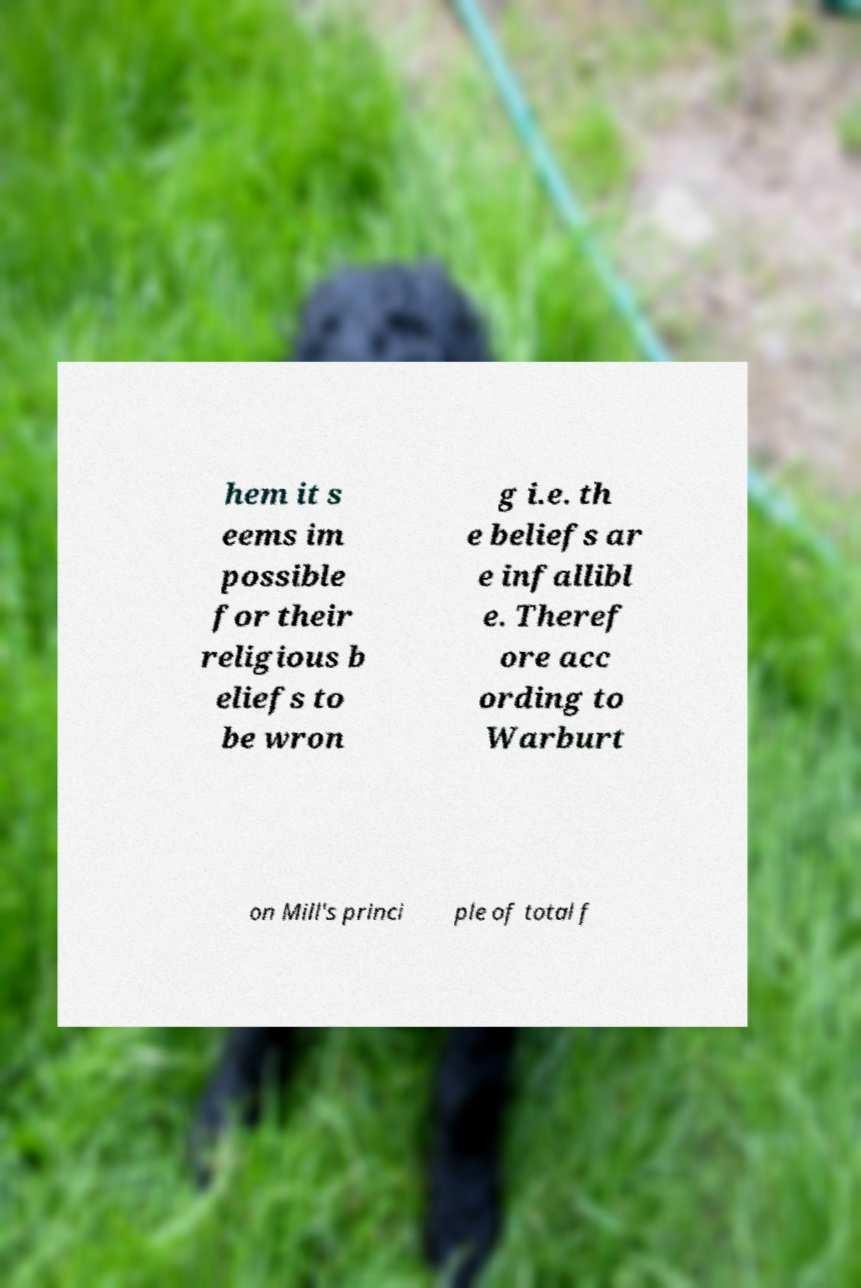What messages or text are displayed in this image? I need them in a readable, typed format. hem it s eems im possible for their religious b eliefs to be wron g i.e. th e beliefs ar e infallibl e. Theref ore acc ording to Warburt on Mill's princi ple of total f 